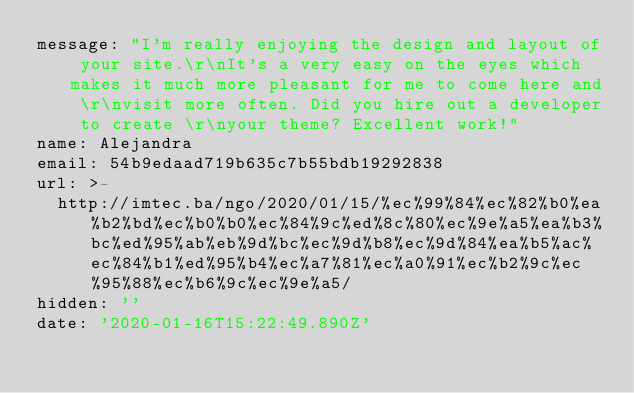<code> <loc_0><loc_0><loc_500><loc_500><_YAML_>message: "I'm really enjoying the design and layout of your site.\r\nIt's a very easy on the eyes which makes it much more pleasant for me to come here and \r\nvisit more often. Did you hire out a developer to create \r\nyour theme? Excellent work!"
name: Alejandra
email: 54b9edaad719b635c7b55bdb19292838
url: >-
  http://imtec.ba/ngo/2020/01/15/%ec%99%84%ec%82%b0%ea%b2%bd%ec%b0%b0%ec%84%9c%ed%8c%80%ec%9e%a5%ea%b3%bc%ed%95%ab%eb%9d%bc%ec%9d%b8%ec%9d%84%ea%b5%ac%ec%84%b1%ed%95%b4%ec%a7%81%ec%a0%91%ec%b2%9c%ec%95%88%ec%b6%9c%ec%9e%a5/
hidden: ''
date: '2020-01-16T15:22:49.890Z'
</code> 